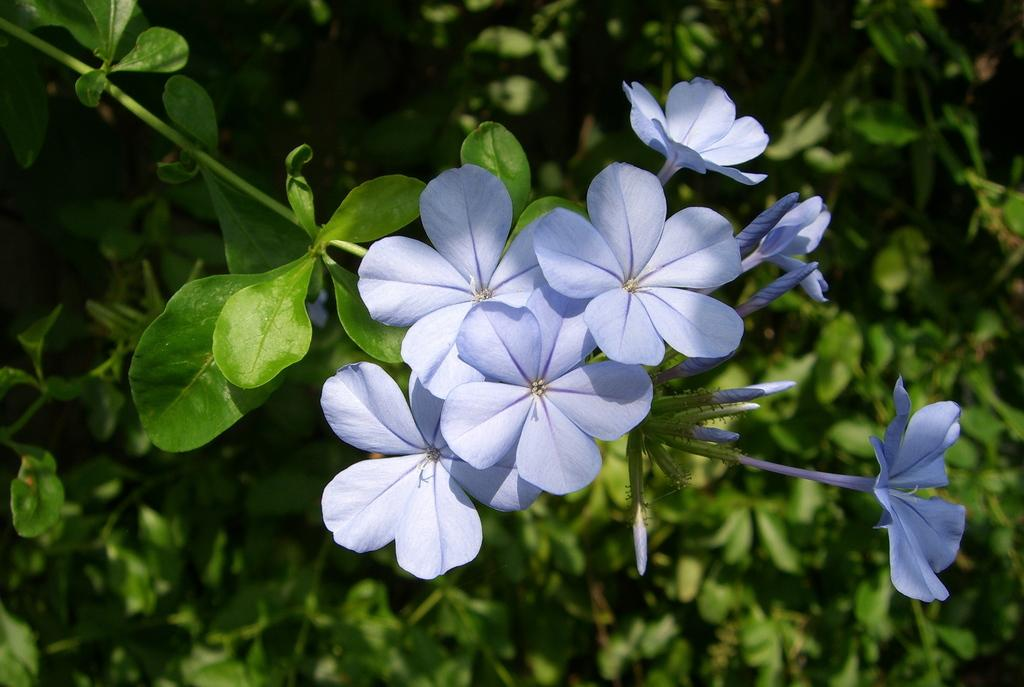What color are the flowers in the image? The flowers in the image are violet color. How are the flowers arranged in the image? The flowers are on a stem. What is the color of the background in the image? The background of the image is green and blurred. Who is the owner of the quince tree in the image? There is no quince tree present in the image, so it is not possible to determine the owner. 